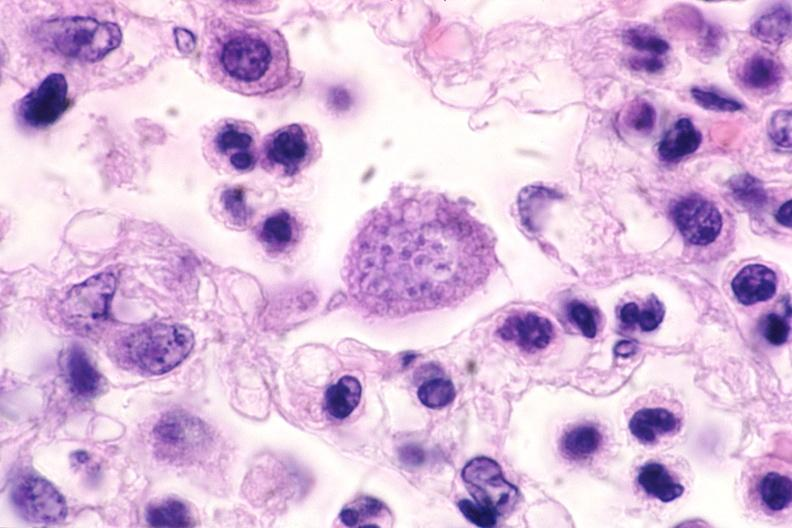what is present?
Answer the question using a single word or phrase. Nervous 